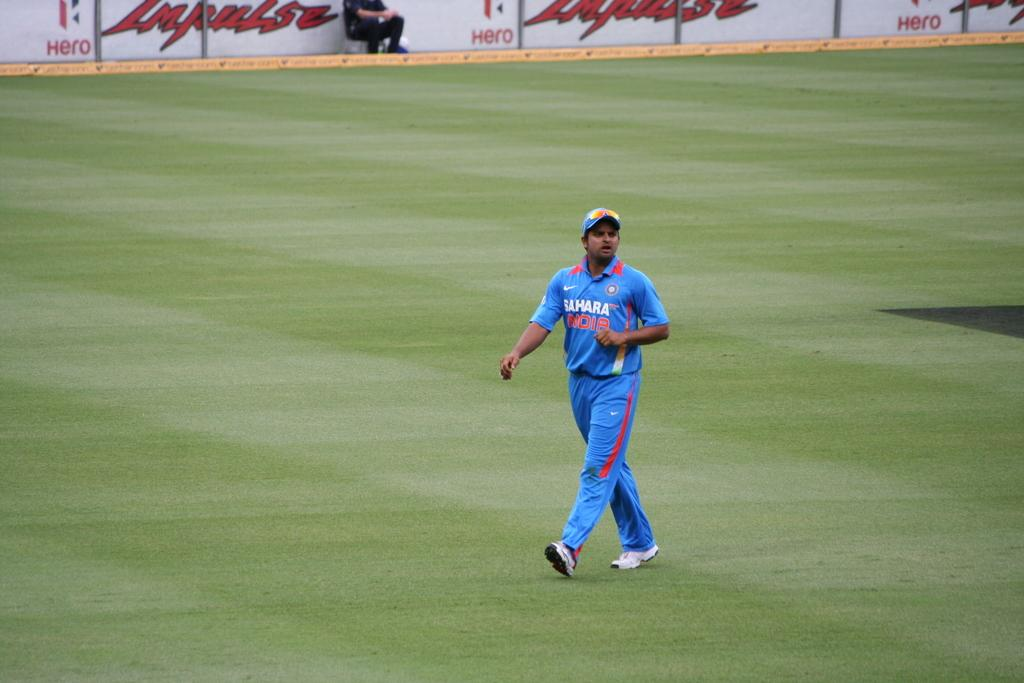<image>
Provide a brief description of the given image. The team here is sponsored by the company Nike 